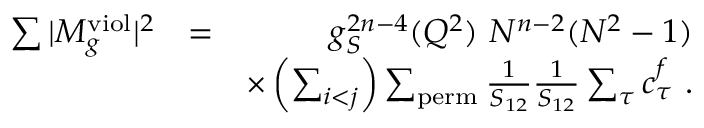Convert formula to latex. <formula><loc_0><loc_0><loc_500><loc_500>\begin{array} { r l r } { \sum | M _ { g } ^ { v i o l } | ^ { 2 } } & { = } & { g _ { S } ^ { 2 n - 4 } ( Q ^ { 2 } ) N ^ { n - 2 } ( N ^ { 2 } - 1 ) } \\ & { \times \left ( \sum _ { i < j } \right ) \sum _ { p e r m } \frac { 1 } { S _ { 1 2 } } \frac { 1 } { S _ { 1 2 } } \sum _ { \tau } c _ { \tau } ^ { f } . } \end{array}</formula> 